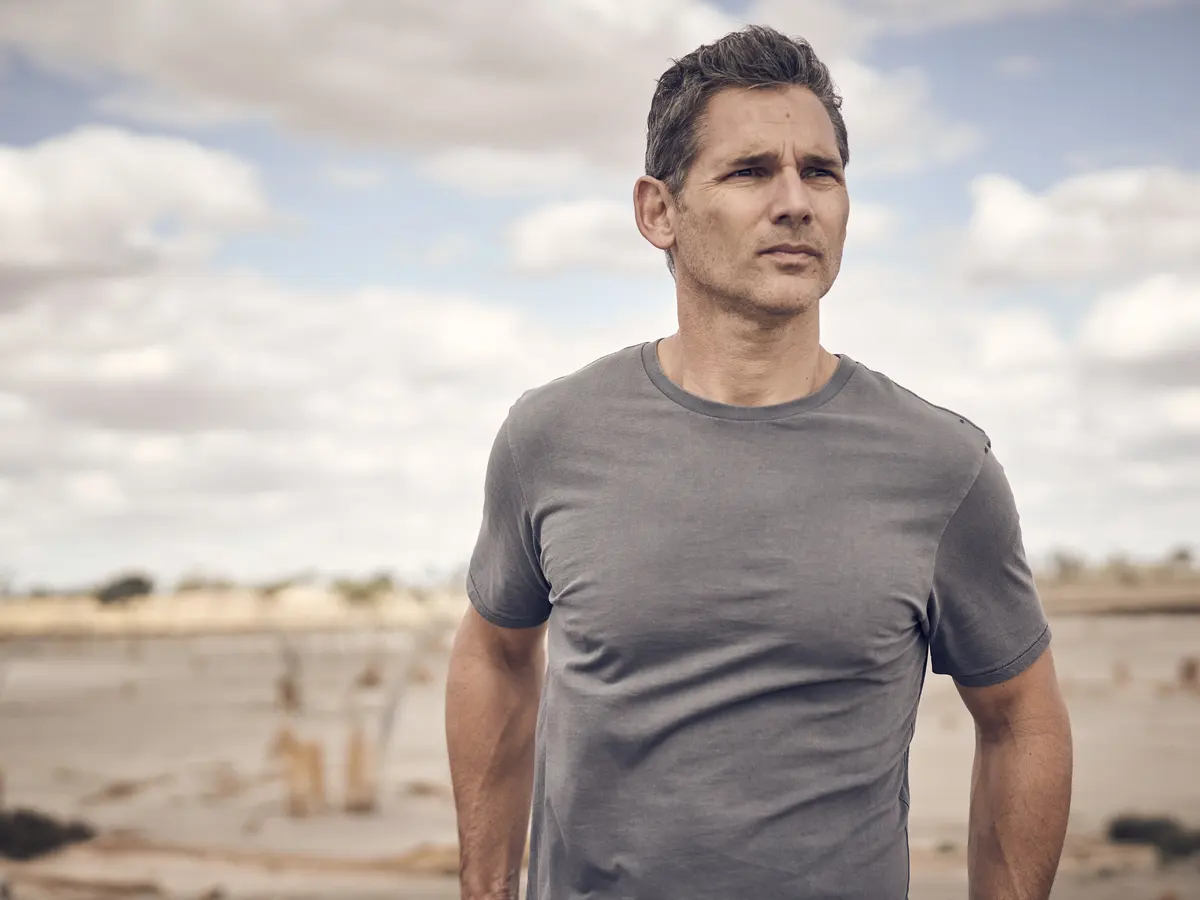Imagine a backstory for the man in the image. What events led him to this moment? The man in the image has a rich backstory filled with both triumphs and tribulations. He might have just experienced a pivotal life event—a recent breakup, the loss of a loved one, or perhaps a career change that has left him questioning his future. He came to the beach, a place of solace from his childhood, to gather his thoughts and find clarity. The overcast sky mirrors his inner turmoil, while the vast horizon represents the possibilities that lie ahead. 